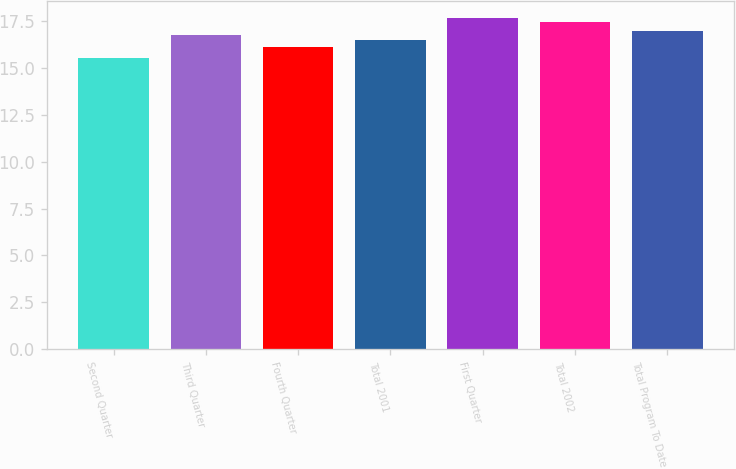Convert chart. <chart><loc_0><loc_0><loc_500><loc_500><bar_chart><fcel>Second Quarter<fcel>Third Quarter<fcel>Fourth Quarter<fcel>Total 2001<fcel>First Quarter<fcel>Total 2002<fcel>Total Program To Date<nl><fcel>15.55<fcel>16.75<fcel>16.12<fcel>16.5<fcel>17.67<fcel>17.47<fcel>16.95<nl></chart> 